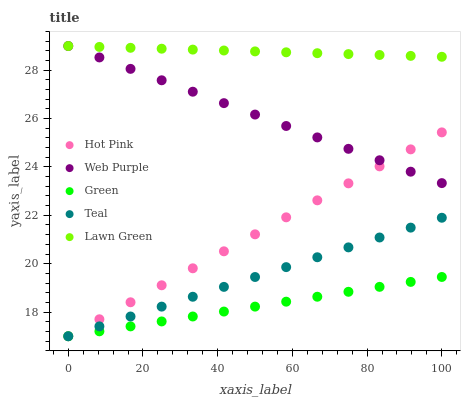Does Green have the minimum area under the curve?
Answer yes or no. Yes. Does Lawn Green have the maximum area under the curve?
Answer yes or no. Yes. Does Web Purple have the minimum area under the curve?
Answer yes or no. No. Does Web Purple have the maximum area under the curve?
Answer yes or no. No. Is Teal the smoothest?
Answer yes or no. Yes. Is Hot Pink the roughest?
Answer yes or no. Yes. Is Web Purple the smoothest?
Answer yes or no. No. Is Web Purple the roughest?
Answer yes or no. No. Does Hot Pink have the lowest value?
Answer yes or no. Yes. Does Web Purple have the lowest value?
Answer yes or no. No. Does Web Purple have the highest value?
Answer yes or no. Yes. Does Hot Pink have the highest value?
Answer yes or no. No. Is Hot Pink less than Lawn Green?
Answer yes or no. Yes. Is Web Purple greater than Teal?
Answer yes or no. Yes. Does Lawn Green intersect Web Purple?
Answer yes or no. Yes. Is Lawn Green less than Web Purple?
Answer yes or no. No. Is Lawn Green greater than Web Purple?
Answer yes or no. No. Does Hot Pink intersect Lawn Green?
Answer yes or no. No. 